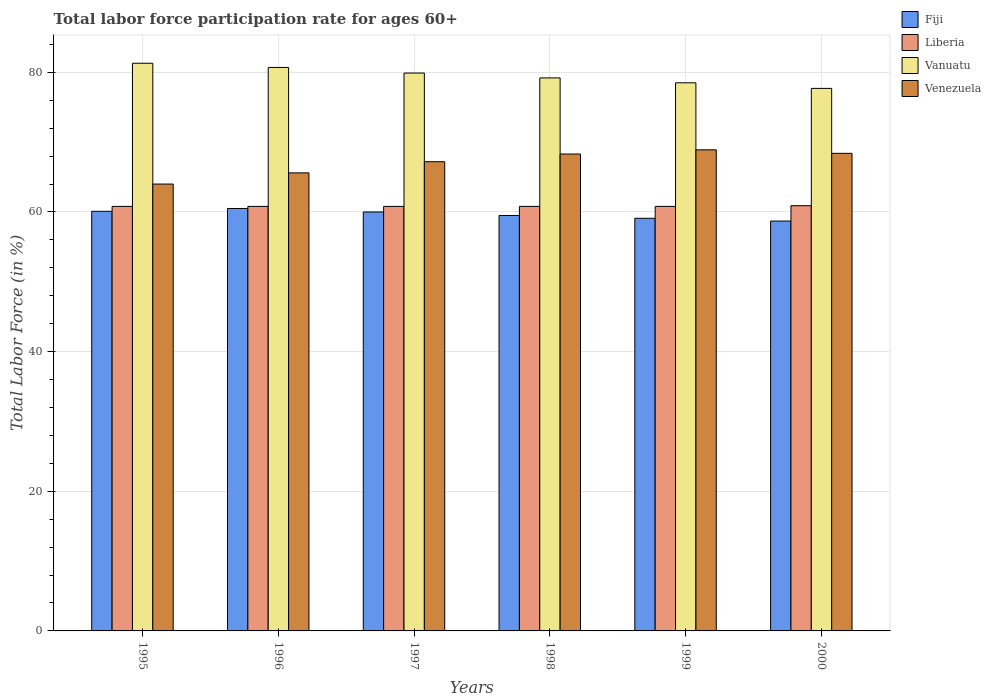How many groups of bars are there?
Offer a very short reply. 6. What is the label of the 1st group of bars from the left?
Give a very brief answer. 1995. What is the labor force participation rate in Vanuatu in 1996?
Ensure brevity in your answer.  80.7. Across all years, what is the maximum labor force participation rate in Vanuatu?
Offer a terse response. 81.3. Across all years, what is the minimum labor force participation rate in Liberia?
Offer a very short reply. 60.8. In which year was the labor force participation rate in Venezuela maximum?
Keep it short and to the point. 1999. What is the total labor force participation rate in Liberia in the graph?
Provide a short and direct response. 364.9. What is the difference between the labor force participation rate in Venezuela in 1995 and that in 1997?
Give a very brief answer. -3.2. What is the difference between the labor force participation rate in Fiji in 1996 and the labor force participation rate in Venezuela in 1999?
Provide a short and direct response. -8.4. What is the average labor force participation rate in Fiji per year?
Keep it short and to the point. 59.65. In the year 1998, what is the difference between the labor force participation rate in Liberia and labor force participation rate in Fiji?
Keep it short and to the point. 1.3. What is the ratio of the labor force participation rate in Fiji in 1996 to that in 1998?
Offer a terse response. 1.02. What is the difference between the highest and the lowest labor force participation rate in Venezuela?
Your answer should be very brief. 4.9. Is the sum of the labor force participation rate in Venezuela in 1997 and 1998 greater than the maximum labor force participation rate in Fiji across all years?
Give a very brief answer. Yes. Is it the case that in every year, the sum of the labor force participation rate in Fiji and labor force participation rate in Vanuatu is greater than the sum of labor force participation rate in Venezuela and labor force participation rate in Liberia?
Your answer should be compact. Yes. What does the 3rd bar from the left in 1998 represents?
Your response must be concise. Vanuatu. What does the 1st bar from the right in 1999 represents?
Ensure brevity in your answer.  Venezuela. Is it the case that in every year, the sum of the labor force participation rate in Venezuela and labor force participation rate in Liberia is greater than the labor force participation rate in Vanuatu?
Keep it short and to the point. Yes. How many bars are there?
Your answer should be compact. 24. How many years are there in the graph?
Provide a succinct answer. 6. Are the values on the major ticks of Y-axis written in scientific E-notation?
Keep it short and to the point. No. Does the graph contain any zero values?
Your answer should be compact. No. How many legend labels are there?
Keep it short and to the point. 4. What is the title of the graph?
Your answer should be very brief. Total labor force participation rate for ages 60+. What is the label or title of the X-axis?
Your answer should be very brief. Years. What is the label or title of the Y-axis?
Your response must be concise. Total Labor Force (in %). What is the Total Labor Force (in %) of Fiji in 1995?
Your answer should be very brief. 60.1. What is the Total Labor Force (in %) of Liberia in 1995?
Ensure brevity in your answer.  60.8. What is the Total Labor Force (in %) in Vanuatu in 1995?
Offer a terse response. 81.3. What is the Total Labor Force (in %) of Venezuela in 1995?
Ensure brevity in your answer.  64. What is the Total Labor Force (in %) of Fiji in 1996?
Give a very brief answer. 60.5. What is the Total Labor Force (in %) in Liberia in 1996?
Provide a short and direct response. 60.8. What is the Total Labor Force (in %) of Vanuatu in 1996?
Your response must be concise. 80.7. What is the Total Labor Force (in %) in Venezuela in 1996?
Keep it short and to the point. 65.6. What is the Total Labor Force (in %) in Liberia in 1997?
Make the answer very short. 60.8. What is the Total Labor Force (in %) in Vanuatu in 1997?
Provide a short and direct response. 79.9. What is the Total Labor Force (in %) in Venezuela in 1997?
Your answer should be very brief. 67.2. What is the Total Labor Force (in %) of Fiji in 1998?
Give a very brief answer. 59.5. What is the Total Labor Force (in %) in Liberia in 1998?
Offer a terse response. 60.8. What is the Total Labor Force (in %) of Vanuatu in 1998?
Your answer should be compact. 79.2. What is the Total Labor Force (in %) in Venezuela in 1998?
Keep it short and to the point. 68.3. What is the Total Labor Force (in %) of Fiji in 1999?
Provide a short and direct response. 59.1. What is the Total Labor Force (in %) in Liberia in 1999?
Your response must be concise. 60.8. What is the Total Labor Force (in %) in Vanuatu in 1999?
Your response must be concise. 78.5. What is the Total Labor Force (in %) in Venezuela in 1999?
Your answer should be compact. 68.9. What is the Total Labor Force (in %) in Fiji in 2000?
Offer a terse response. 58.7. What is the Total Labor Force (in %) in Liberia in 2000?
Offer a very short reply. 60.9. What is the Total Labor Force (in %) in Vanuatu in 2000?
Your response must be concise. 77.7. What is the Total Labor Force (in %) of Venezuela in 2000?
Keep it short and to the point. 68.4. Across all years, what is the maximum Total Labor Force (in %) in Fiji?
Give a very brief answer. 60.5. Across all years, what is the maximum Total Labor Force (in %) of Liberia?
Keep it short and to the point. 60.9. Across all years, what is the maximum Total Labor Force (in %) in Vanuatu?
Make the answer very short. 81.3. Across all years, what is the maximum Total Labor Force (in %) of Venezuela?
Give a very brief answer. 68.9. Across all years, what is the minimum Total Labor Force (in %) of Fiji?
Keep it short and to the point. 58.7. Across all years, what is the minimum Total Labor Force (in %) of Liberia?
Give a very brief answer. 60.8. Across all years, what is the minimum Total Labor Force (in %) of Vanuatu?
Your answer should be compact. 77.7. Across all years, what is the minimum Total Labor Force (in %) in Venezuela?
Offer a very short reply. 64. What is the total Total Labor Force (in %) in Fiji in the graph?
Ensure brevity in your answer.  357.9. What is the total Total Labor Force (in %) in Liberia in the graph?
Ensure brevity in your answer.  364.9. What is the total Total Labor Force (in %) in Vanuatu in the graph?
Your answer should be very brief. 477.3. What is the total Total Labor Force (in %) in Venezuela in the graph?
Offer a very short reply. 402.4. What is the difference between the Total Labor Force (in %) in Fiji in 1995 and that in 1996?
Provide a short and direct response. -0.4. What is the difference between the Total Labor Force (in %) of Venezuela in 1995 and that in 1996?
Provide a short and direct response. -1.6. What is the difference between the Total Labor Force (in %) in Fiji in 1995 and that in 1997?
Offer a terse response. 0.1. What is the difference between the Total Labor Force (in %) of Liberia in 1995 and that in 1997?
Ensure brevity in your answer.  0. What is the difference between the Total Labor Force (in %) in Liberia in 1995 and that in 1998?
Offer a very short reply. 0. What is the difference between the Total Labor Force (in %) of Vanuatu in 1995 and that in 1998?
Make the answer very short. 2.1. What is the difference between the Total Labor Force (in %) in Venezuela in 1995 and that in 1998?
Offer a terse response. -4.3. What is the difference between the Total Labor Force (in %) of Liberia in 1995 and that in 1999?
Keep it short and to the point. 0. What is the difference between the Total Labor Force (in %) of Venezuela in 1995 and that in 1999?
Your response must be concise. -4.9. What is the difference between the Total Labor Force (in %) in Vanuatu in 1995 and that in 2000?
Offer a terse response. 3.6. What is the difference between the Total Labor Force (in %) of Liberia in 1996 and that in 1997?
Offer a terse response. 0. What is the difference between the Total Labor Force (in %) of Vanuatu in 1996 and that in 1997?
Give a very brief answer. 0.8. What is the difference between the Total Labor Force (in %) of Liberia in 1996 and that in 1998?
Offer a very short reply. 0. What is the difference between the Total Labor Force (in %) of Vanuatu in 1996 and that in 1998?
Provide a short and direct response. 1.5. What is the difference between the Total Labor Force (in %) of Venezuela in 1996 and that in 1999?
Offer a terse response. -3.3. What is the difference between the Total Labor Force (in %) in Liberia in 1996 and that in 2000?
Give a very brief answer. -0.1. What is the difference between the Total Labor Force (in %) in Vanuatu in 1996 and that in 2000?
Offer a terse response. 3. What is the difference between the Total Labor Force (in %) of Venezuela in 1996 and that in 2000?
Offer a very short reply. -2.8. What is the difference between the Total Labor Force (in %) in Fiji in 1997 and that in 1999?
Offer a terse response. 0.9. What is the difference between the Total Labor Force (in %) in Liberia in 1997 and that in 1999?
Provide a succinct answer. 0. What is the difference between the Total Labor Force (in %) of Vanuatu in 1997 and that in 1999?
Offer a very short reply. 1.4. What is the difference between the Total Labor Force (in %) in Fiji in 1997 and that in 2000?
Provide a short and direct response. 1.3. What is the difference between the Total Labor Force (in %) in Liberia in 1997 and that in 2000?
Make the answer very short. -0.1. What is the difference between the Total Labor Force (in %) of Venezuela in 1997 and that in 2000?
Offer a very short reply. -1.2. What is the difference between the Total Labor Force (in %) in Liberia in 1998 and that in 1999?
Give a very brief answer. 0. What is the difference between the Total Labor Force (in %) of Vanuatu in 1998 and that in 1999?
Your answer should be very brief. 0.7. What is the difference between the Total Labor Force (in %) of Venezuela in 1998 and that in 1999?
Keep it short and to the point. -0.6. What is the difference between the Total Labor Force (in %) of Liberia in 1998 and that in 2000?
Offer a very short reply. -0.1. What is the difference between the Total Labor Force (in %) of Vanuatu in 1998 and that in 2000?
Your answer should be compact. 1.5. What is the difference between the Total Labor Force (in %) in Fiji in 1999 and that in 2000?
Offer a very short reply. 0.4. What is the difference between the Total Labor Force (in %) in Fiji in 1995 and the Total Labor Force (in %) in Liberia in 1996?
Keep it short and to the point. -0.7. What is the difference between the Total Labor Force (in %) in Fiji in 1995 and the Total Labor Force (in %) in Vanuatu in 1996?
Your answer should be compact. -20.6. What is the difference between the Total Labor Force (in %) of Fiji in 1995 and the Total Labor Force (in %) of Venezuela in 1996?
Make the answer very short. -5.5. What is the difference between the Total Labor Force (in %) of Liberia in 1995 and the Total Labor Force (in %) of Vanuatu in 1996?
Offer a very short reply. -19.9. What is the difference between the Total Labor Force (in %) of Liberia in 1995 and the Total Labor Force (in %) of Venezuela in 1996?
Offer a very short reply. -4.8. What is the difference between the Total Labor Force (in %) in Fiji in 1995 and the Total Labor Force (in %) in Vanuatu in 1997?
Provide a short and direct response. -19.8. What is the difference between the Total Labor Force (in %) of Fiji in 1995 and the Total Labor Force (in %) of Venezuela in 1997?
Give a very brief answer. -7.1. What is the difference between the Total Labor Force (in %) of Liberia in 1995 and the Total Labor Force (in %) of Vanuatu in 1997?
Your response must be concise. -19.1. What is the difference between the Total Labor Force (in %) in Vanuatu in 1995 and the Total Labor Force (in %) in Venezuela in 1997?
Ensure brevity in your answer.  14.1. What is the difference between the Total Labor Force (in %) of Fiji in 1995 and the Total Labor Force (in %) of Vanuatu in 1998?
Your response must be concise. -19.1. What is the difference between the Total Labor Force (in %) in Fiji in 1995 and the Total Labor Force (in %) in Venezuela in 1998?
Provide a short and direct response. -8.2. What is the difference between the Total Labor Force (in %) in Liberia in 1995 and the Total Labor Force (in %) in Vanuatu in 1998?
Provide a succinct answer. -18.4. What is the difference between the Total Labor Force (in %) of Vanuatu in 1995 and the Total Labor Force (in %) of Venezuela in 1998?
Provide a short and direct response. 13. What is the difference between the Total Labor Force (in %) of Fiji in 1995 and the Total Labor Force (in %) of Vanuatu in 1999?
Give a very brief answer. -18.4. What is the difference between the Total Labor Force (in %) of Fiji in 1995 and the Total Labor Force (in %) of Venezuela in 1999?
Your answer should be compact. -8.8. What is the difference between the Total Labor Force (in %) of Liberia in 1995 and the Total Labor Force (in %) of Vanuatu in 1999?
Your response must be concise. -17.7. What is the difference between the Total Labor Force (in %) in Vanuatu in 1995 and the Total Labor Force (in %) in Venezuela in 1999?
Make the answer very short. 12.4. What is the difference between the Total Labor Force (in %) of Fiji in 1995 and the Total Labor Force (in %) of Vanuatu in 2000?
Your response must be concise. -17.6. What is the difference between the Total Labor Force (in %) in Fiji in 1995 and the Total Labor Force (in %) in Venezuela in 2000?
Offer a terse response. -8.3. What is the difference between the Total Labor Force (in %) in Liberia in 1995 and the Total Labor Force (in %) in Vanuatu in 2000?
Make the answer very short. -16.9. What is the difference between the Total Labor Force (in %) of Vanuatu in 1995 and the Total Labor Force (in %) of Venezuela in 2000?
Provide a succinct answer. 12.9. What is the difference between the Total Labor Force (in %) of Fiji in 1996 and the Total Labor Force (in %) of Liberia in 1997?
Ensure brevity in your answer.  -0.3. What is the difference between the Total Labor Force (in %) of Fiji in 1996 and the Total Labor Force (in %) of Vanuatu in 1997?
Ensure brevity in your answer.  -19.4. What is the difference between the Total Labor Force (in %) of Fiji in 1996 and the Total Labor Force (in %) of Venezuela in 1997?
Provide a succinct answer. -6.7. What is the difference between the Total Labor Force (in %) in Liberia in 1996 and the Total Labor Force (in %) in Vanuatu in 1997?
Your answer should be compact. -19.1. What is the difference between the Total Labor Force (in %) of Liberia in 1996 and the Total Labor Force (in %) of Venezuela in 1997?
Provide a succinct answer. -6.4. What is the difference between the Total Labor Force (in %) of Vanuatu in 1996 and the Total Labor Force (in %) of Venezuela in 1997?
Offer a very short reply. 13.5. What is the difference between the Total Labor Force (in %) of Fiji in 1996 and the Total Labor Force (in %) of Liberia in 1998?
Offer a very short reply. -0.3. What is the difference between the Total Labor Force (in %) in Fiji in 1996 and the Total Labor Force (in %) in Vanuatu in 1998?
Give a very brief answer. -18.7. What is the difference between the Total Labor Force (in %) in Fiji in 1996 and the Total Labor Force (in %) in Venezuela in 1998?
Ensure brevity in your answer.  -7.8. What is the difference between the Total Labor Force (in %) of Liberia in 1996 and the Total Labor Force (in %) of Vanuatu in 1998?
Make the answer very short. -18.4. What is the difference between the Total Labor Force (in %) in Vanuatu in 1996 and the Total Labor Force (in %) in Venezuela in 1998?
Your answer should be very brief. 12.4. What is the difference between the Total Labor Force (in %) of Fiji in 1996 and the Total Labor Force (in %) of Liberia in 1999?
Offer a terse response. -0.3. What is the difference between the Total Labor Force (in %) of Fiji in 1996 and the Total Labor Force (in %) of Venezuela in 1999?
Offer a terse response. -8.4. What is the difference between the Total Labor Force (in %) in Liberia in 1996 and the Total Labor Force (in %) in Vanuatu in 1999?
Offer a terse response. -17.7. What is the difference between the Total Labor Force (in %) of Vanuatu in 1996 and the Total Labor Force (in %) of Venezuela in 1999?
Provide a succinct answer. 11.8. What is the difference between the Total Labor Force (in %) in Fiji in 1996 and the Total Labor Force (in %) in Vanuatu in 2000?
Your response must be concise. -17.2. What is the difference between the Total Labor Force (in %) of Liberia in 1996 and the Total Labor Force (in %) of Vanuatu in 2000?
Offer a terse response. -16.9. What is the difference between the Total Labor Force (in %) in Fiji in 1997 and the Total Labor Force (in %) in Vanuatu in 1998?
Your response must be concise. -19.2. What is the difference between the Total Labor Force (in %) of Liberia in 1997 and the Total Labor Force (in %) of Vanuatu in 1998?
Keep it short and to the point. -18.4. What is the difference between the Total Labor Force (in %) of Fiji in 1997 and the Total Labor Force (in %) of Liberia in 1999?
Offer a terse response. -0.8. What is the difference between the Total Labor Force (in %) in Fiji in 1997 and the Total Labor Force (in %) in Vanuatu in 1999?
Your answer should be compact. -18.5. What is the difference between the Total Labor Force (in %) of Liberia in 1997 and the Total Labor Force (in %) of Vanuatu in 1999?
Your answer should be very brief. -17.7. What is the difference between the Total Labor Force (in %) in Liberia in 1997 and the Total Labor Force (in %) in Venezuela in 1999?
Provide a succinct answer. -8.1. What is the difference between the Total Labor Force (in %) in Fiji in 1997 and the Total Labor Force (in %) in Liberia in 2000?
Keep it short and to the point. -0.9. What is the difference between the Total Labor Force (in %) of Fiji in 1997 and the Total Labor Force (in %) of Vanuatu in 2000?
Offer a terse response. -17.7. What is the difference between the Total Labor Force (in %) in Fiji in 1997 and the Total Labor Force (in %) in Venezuela in 2000?
Keep it short and to the point. -8.4. What is the difference between the Total Labor Force (in %) of Liberia in 1997 and the Total Labor Force (in %) of Vanuatu in 2000?
Keep it short and to the point. -16.9. What is the difference between the Total Labor Force (in %) in Liberia in 1997 and the Total Labor Force (in %) in Venezuela in 2000?
Keep it short and to the point. -7.6. What is the difference between the Total Labor Force (in %) in Fiji in 1998 and the Total Labor Force (in %) in Liberia in 1999?
Offer a very short reply. -1.3. What is the difference between the Total Labor Force (in %) in Fiji in 1998 and the Total Labor Force (in %) in Vanuatu in 1999?
Give a very brief answer. -19. What is the difference between the Total Labor Force (in %) of Fiji in 1998 and the Total Labor Force (in %) of Venezuela in 1999?
Keep it short and to the point. -9.4. What is the difference between the Total Labor Force (in %) of Liberia in 1998 and the Total Labor Force (in %) of Vanuatu in 1999?
Ensure brevity in your answer.  -17.7. What is the difference between the Total Labor Force (in %) of Fiji in 1998 and the Total Labor Force (in %) of Liberia in 2000?
Your answer should be compact. -1.4. What is the difference between the Total Labor Force (in %) of Fiji in 1998 and the Total Labor Force (in %) of Vanuatu in 2000?
Provide a short and direct response. -18.2. What is the difference between the Total Labor Force (in %) of Liberia in 1998 and the Total Labor Force (in %) of Vanuatu in 2000?
Provide a succinct answer. -16.9. What is the difference between the Total Labor Force (in %) in Fiji in 1999 and the Total Labor Force (in %) in Vanuatu in 2000?
Your answer should be very brief. -18.6. What is the difference between the Total Labor Force (in %) of Liberia in 1999 and the Total Labor Force (in %) of Vanuatu in 2000?
Provide a short and direct response. -16.9. What is the average Total Labor Force (in %) in Fiji per year?
Keep it short and to the point. 59.65. What is the average Total Labor Force (in %) of Liberia per year?
Offer a very short reply. 60.82. What is the average Total Labor Force (in %) in Vanuatu per year?
Offer a terse response. 79.55. What is the average Total Labor Force (in %) of Venezuela per year?
Give a very brief answer. 67.07. In the year 1995, what is the difference between the Total Labor Force (in %) of Fiji and Total Labor Force (in %) of Vanuatu?
Your answer should be compact. -21.2. In the year 1995, what is the difference between the Total Labor Force (in %) in Fiji and Total Labor Force (in %) in Venezuela?
Provide a short and direct response. -3.9. In the year 1995, what is the difference between the Total Labor Force (in %) in Liberia and Total Labor Force (in %) in Vanuatu?
Offer a very short reply. -20.5. In the year 1995, what is the difference between the Total Labor Force (in %) of Liberia and Total Labor Force (in %) of Venezuela?
Ensure brevity in your answer.  -3.2. In the year 1996, what is the difference between the Total Labor Force (in %) of Fiji and Total Labor Force (in %) of Vanuatu?
Provide a succinct answer. -20.2. In the year 1996, what is the difference between the Total Labor Force (in %) in Liberia and Total Labor Force (in %) in Vanuatu?
Give a very brief answer. -19.9. In the year 1996, what is the difference between the Total Labor Force (in %) in Liberia and Total Labor Force (in %) in Venezuela?
Your answer should be compact. -4.8. In the year 1997, what is the difference between the Total Labor Force (in %) in Fiji and Total Labor Force (in %) in Liberia?
Your answer should be compact. -0.8. In the year 1997, what is the difference between the Total Labor Force (in %) of Fiji and Total Labor Force (in %) of Vanuatu?
Your answer should be very brief. -19.9. In the year 1997, what is the difference between the Total Labor Force (in %) of Fiji and Total Labor Force (in %) of Venezuela?
Offer a very short reply. -7.2. In the year 1997, what is the difference between the Total Labor Force (in %) in Liberia and Total Labor Force (in %) in Vanuatu?
Your answer should be very brief. -19.1. In the year 1997, what is the difference between the Total Labor Force (in %) of Liberia and Total Labor Force (in %) of Venezuela?
Your answer should be very brief. -6.4. In the year 1997, what is the difference between the Total Labor Force (in %) of Vanuatu and Total Labor Force (in %) of Venezuela?
Provide a short and direct response. 12.7. In the year 1998, what is the difference between the Total Labor Force (in %) of Fiji and Total Labor Force (in %) of Vanuatu?
Ensure brevity in your answer.  -19.7. In the year 1998, what is the difference between the Total Labor Force (in %) in Fiji and Total Labor Force (in %) in Venezuela?
Provide a succinct answer. -8.8. In the year 1998, what is the difference between the Total Labor Force (in %) of Liberia and Total Labor Force (in %) of Vanuatu?
Your answer should be very brief. -18.4. In the year 1998, what is the difference between the Total Labor Force (in %) in Liberia and Total Labor Force (in %) in Venezuela?
Your answer should be very brief. -7.5. In the year 1999, what is the difference between the Total Labor Force (in %) in Fiji and Total Labor Force (in %) in Vanuatu?
Your answer should be compact. -19.4. In the year 1999, what is the difference between the Total Labor Force (in %) in Fiji and Total Labor Force (in %) in Venezuela?
Provide a succinct answer. -9.8. In the year 1999, what is the difference between the Total Labor Force (in %) of Liberia and Total Labor Force (in %) of Vanuatu?
Provide a short and direct response. -17.7. In the year 1999, what is the difference between the Total Labor Force (in %) in Liberia and Total Labor Force (in %) in Venezuela?
Your response must be concise. -8.1. In the year 1999, what is the difference between the Total Labor Force (in %) of Vanuatu and Total Labor Force (in %) of Venezuela?
Ensure brevity in your answer.  9.6. In the year 2000, what is the difference between the Total Labor Force (in %) of Fiji and Total Labor Force (in %) of Liberia?
Make the answer very short. -2.2. In the year 2000, what is the difference between the Total Labor Force (in %) in Fiji and Total Labor Force (in %) in Vanuatu?
Give a very brief answer. -19. In the year 2000, what is the difference between the Total Labor Force (in %) of Fiji and Total Labor Force (in %) of Venezuela?
Keep it short and to the point. -9.7. In the year 2000, what is the difference between the Total Labor Force (in %) of Liberia and Total Labor Force (in %) of Vanuatu?
Ensure brevity in your answer.  -16.8. In the year 2000, what is the difference between the Total Labor Force (in %) of Liberia and Total Labor Force (in %) of Venezuela?
Your answer should be compact. -7.5. What is the ratio of the Total Labor Force (in %) of Liberia in 1995 to that in 1996?
Provide a short and direct response. 1. What is the ratio of the Total Labor Force (in %) in Vanuatu in 1995 to that in 1996?
Your answer should be compact. 1.01. What is the ratio of the Total Labor Force (in %) in Venezuela in 1995 to that in 1996?
Your answer should be compact. 0.98. What is the ratio of the Total Labor Force (in %) of Vanuatu in 1995 to that in 1997?
Make the answer very short. 1.02. What is the ratio of the Total Labor Force (in %) of Fiji in 1995 to that in 1998?
Your answer should be compact. 1.01. What is the ratio of the Total Labor Force (in %) of Liberia in 1995 to that in 1998?
Your answer should be very brief. 1. What is the ratio of the Total Labor Force (in %) of Vanuatu in 1995 to that in 1998?
Your answer should be compact. 1.03. What is the ratio of the Total Labor Force (in %) in Venezuela in 1995 to that in 1998?
Keep it short and to the point. 0.94. What is the ratio of the Total Labor Force (in %) of Fiji in 1995 to that in 1999?
Offer a terse response. 1.02. What is the ratio of the Total Labor Force (in %) of Liberia in 1995 to that in 1999?
Give a very brief answer. 1. What is the ratio of the Total Labor Force (in %) of Vanuatu in 1995 to that in 1999?
Offer a terse response. 1.04. What is the ratio of the Total Labor Force (in %) of Venezuela in 1995 to that in 1999?
Provide a succinct answer. 0.93. What is the ratio of the Total Labor Force (in %) of Fiji in 1995 to that in 2000?
Your answer should be compact. 1.02. What is the ratio of the Total Labor Force (in %) in Vanuatu in 1995 to that in 2000?
Offer a very short reply. 1.05. What is the ratio of the Total Labor Force (in %) of Venezuela in 1995 to that in 2000?
Your response must be concise. 0.94. What is the ratio of the Total Labor Force (in %) of Fiji in 1996 to that in 1997?
Provide a succinct answer. 1.01. What is the ratio of the Total Labor Force (in %) of Liberia in 1996 to that in 1997?
Your answer should be compact. 1. What is the ratio of the Total Labor Force (in %) in Vanuatu in 1996 to that in 1997?
Keep it short and to the point. 1.01. What is the ratio of the Total Labor Force (in %) in Venezuela in 1996 to that in 1997?
Make the answer very short. 0.98. What is the ratio of the Total Labor Force (in %) in Fiji in 1996 to that in 1998?
Give a very brief answer. 1.02. What is the ratio of the Total Labor Force (in %) in Vanuatu in 1996 to that in 1998?
Offer a very short reply. 1.02. What is the ratio of the Total Labor Force (in %) of Venezuela in 1996 to that in 1998?
Provide a succinct answer. 0.96. What is the ratio of the Total Labor Force (in %) of Fiji in 1996 to that in 1999?
Give a very brief answer. 1.02. What is the ratio of the Total Labor Force (in %) in Liberia in 1996 to that in 1999?
Provide a short and direct response. 1. What is the ratio of the Total Labor Force (in %) of Vanuatu in 1996 to that in 1999?
Ensure brevity in your answer.  1.03. What is the ratio of the Total Labor Force (in %) in Venezuela in 1996 to that in 1999?
Your response must be concise. 0.95. What is the ratio of the Total Labor Force (in %) of Fiji in 1996 to that in 2000?
Your response must be concise. 1.03. What is the ratio of the Total Labor Force (in %) of Vanuatu in 1996 to that in 2000?
Provide a short and direct response. 1.04. What is the ratio of the Total Labor Force (in %) in Venezuela in 1996 to that in 2000?
Make the answer very short. 0.96. What is the ratio of the Total Labor Force (in %) of Fiji in 1997 to that in 1998?
Provide a succinct answer. 1.01. What is the ratio of the Total Labor Force (in %) of Liberia in 1997 to that in 1998?
Keep it short and to the point. 1. What is the ratio of the Total Labor Force (in %) in Vanuatu in 1997 to that in 1998?
Give a very brief answer. 1.01. What is the ratio of the Total Labor Force (in %) of Venezuela in 1997 to that in 1998?
Offer a terse response. 0.98. What is the ratio of the Total Labor Force (in %) in Fiji in 1997 to that in 1999?
Give a very brief answer. 1.02. What is the ratio of the Total Labor Force (in %) of Vanuatu in 1997 to that in 1999?
Provide a short and direct response. 1.02. What is the ratio of the Total Labor Force (in %) in Venezuela in 1997 to that in 1999?
Provide a succinct answer. 0.98. What is the ratio of the Total Labor Force (in %) in Fiji in 1997 to that in 2000?
Provide a succinct answer. 1.02. What is the ratio of the Total Labor Force (in %) in Vanuatu in 1997 to that in 2000?
Make the answer very short. 1.03. What is the ratio of the Total Labor Force (in %) in Venezuela in 1997 to that in 2000?
Provide a succinct answer. 0.98. What is the ratio of the Total Labor Force (in %) of Fiji in 1998 to that in 1999?
Keep it short and to the point. 1.01. What is the ratio of the Total Labor Force (in %) in Vanuatu in 1998 to that in 1999?
Make the answer very short. 1.01. What is the ratio of the Total Labor Force (in %) of Fiji in 1998 to that in 2000?
Your response must be concise. 1.01. What is the ratio of the Total Labor Force (in %) in Liberia in 1998 to that in 2000?
Provide a succinct answer. 1. What is the ratio of the Total Labor Force (in %) of Vanuatu in 1998 to that in 2000?
Make the answer very short. 1.02. What is the ratio of the Total Labor Force (in %) in Fiji in 1999 to that in 2000?
Offer a terse response. 1.01. What is the ratio of the Total Labor Force (in %) of Vanuatu in 1999 to that in 2000?
Give a very brief answer. 1.01. What is the ratio of the Total Labor Force (in %) in Venezuela in 1999 to that in 2000?
Your response must be concise. 1.01. What is the difference between the highest and the second highest Total Labor Force (in %) of Vanuatu?
Keep it short and to the point. 0.6. What is the difference between the highest and the lowest Total Labor Force (in %) in Liberia?
Your answer should be compact. 0.1. 